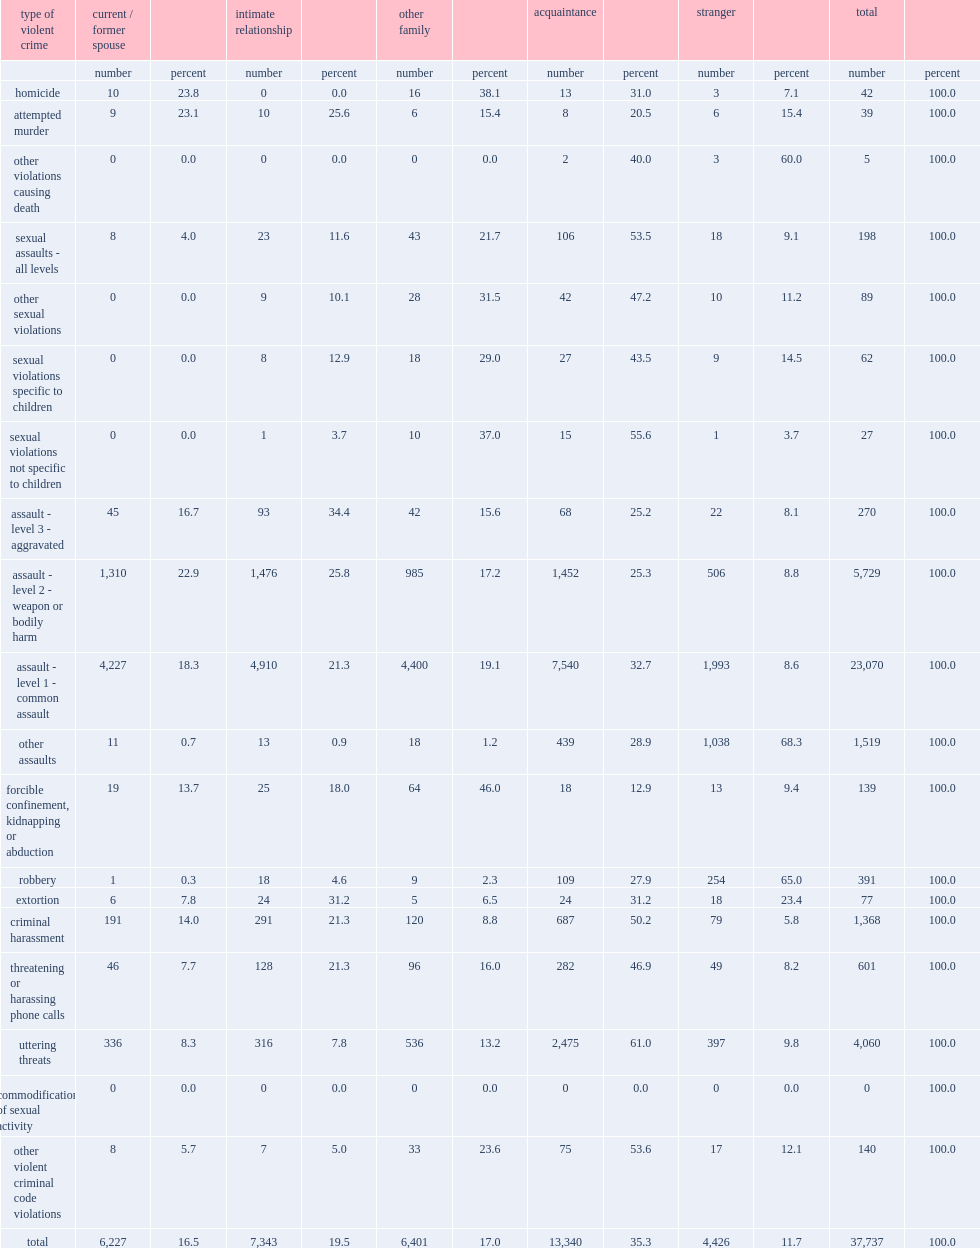What was the percentage of individuals known or related to the offenders among victims of violent crimes committed by females in 2015? 88.3. What was the percentage of strangers to the victims among the accused females of violent crimes in 2015? 11.7. What was the percentage of acquaintances to the offenders among victims of violent crimes committed by females in 2015? 35.3. What was the percentage of other family members to the offenders among victims of violent crimes committed by females in 2015? 17.0. What was the percentage of intimate partners to the offenders among victims of violent crimes committed by females in 2015? 19.5. What was the percentage of current/former spouses to the offenders among victims of violent crimes committed by females in 2015? 16.5. What was the percentage of spouses or other intimate partners among victims of females accused of assault level 1 (common assault) in 2015? 39.6. What was the percentage of spouses or other intimate partners among victims of females accused of assault level 2 (assault with a weapon or assault causing bodily harm) in 2015? 48.7. What was the percentage of spouses or other intimate partners among victims of females accused of assault level 3 (assault with a weapon) in 2015? 51.1. What was the percentage of acquaintances to their victims among all females accused of sexual assault in 2015? 53.5. What was the percentage of acquaintances to their victims among all females accused of criminal harassment offences in 2015? 50.2. What was the percentage of acquaintances to their victims among all females accused of threatening or harassing phone calls in 2015? 46.9. What was the percentage of other assaults in the violent crimes perpetrated by females against strangers in 2015? 68.3. What was the percentage of the robbery in the violent crimes perpetrated by females against strangers in 2015? 65.0. What was the percentage of other violations causing death in the violent crimes perpetrated by females against strangers in 2015? 60.0. What was the percentage of extortion in the violent crimes perpetrated by females against strangers in 2015? 23.4. 